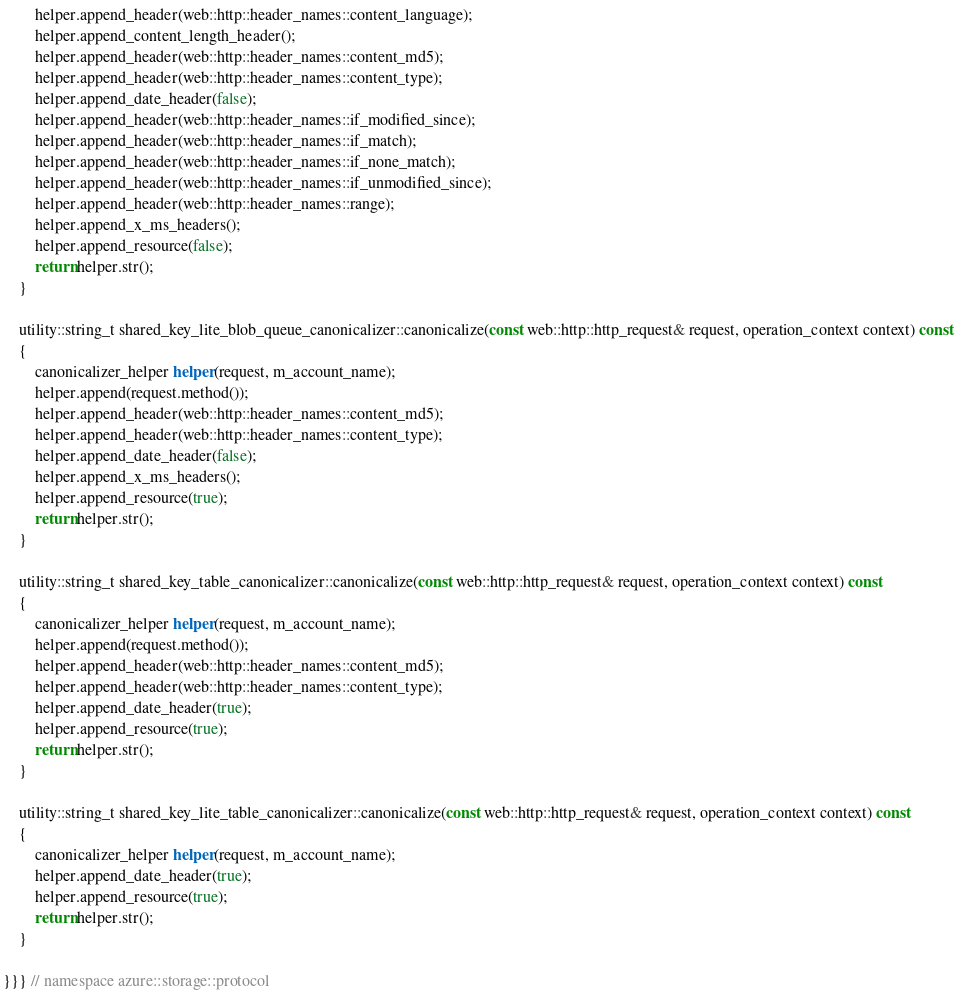Convert code to text. <code><loc_0><loc_0><loc_500><loc_500><_C++_>        helper.append_header(web::http::header_names::content_language);
        helper.append_content_length_header();
        helper.append_header(web::http::header_names::content_md5);
        helper.append_header(web::http::header_names::content_type);
        helper.append_date_header(false);
        helper.append_header(web::http::header_names::if_modified_since);
        helper.append_header(web::http::header_names::if_match);
        helper.append_header(web::http::header_names::if_none_match);
        helper.append_header(web::http::header_names::if_unmodified_since);
        helper.append_header(web::http::header_names::range);
        helper.append_x_ms_headers();
        helper.append_resource(false);
        return helper.str();
    }

    utility::string_t shared_key_lite_blob_queue_canonicalizer::canonicalize(const web::http::http_request& request, operation_context context) const
    {
        canonicalizer_helper helper(request, m_account_name);
        helper.append(request.method());
        helper.append_header(web::http::header_names::content_md5);
        helper.append_header(web::http::header_names::content_type);
        helper.append_date_header(false);
        helper.append_x_ms_headers();
        helper.append_resource(true);
        return helper.str();
    }

    utility::string_t shared_key_table_canonicalizer::canonicalize(const web::http::http_request& request, operation_context context) const
    {
        canonicalizer_helper helper(request, m_account_name);
        helper.append(request.method());
        helper.append_header(web::http::header_names::content_md5);
        helper.append_header(web::http::header_names::content_type);
        helper.append_date_header(true);
        helper.append_resource(true);
        return helper.str();
    }

    utility::string_t shared_key_lite_table_canonicalizer::canonicalize(const web::http::http_request& request, operation_context context) const
    {
        canonicalizer_helper helper(request, m_account_name);
        helper.append_date_header(true);
        helper.append_resource(true);
        return helper.str();
    }

}}} // namespace azure::storage::protocol
</code> 